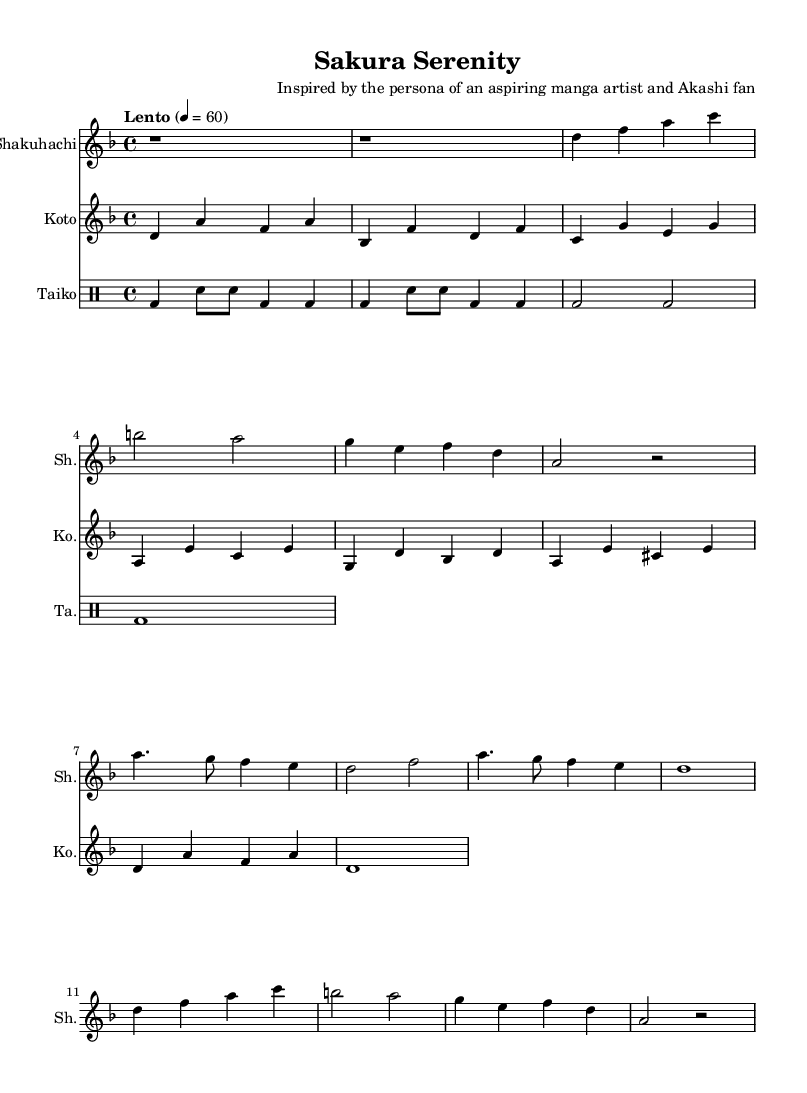What is the key signature of this music? The key signature is D minor, which has one flat (B♭) and indicates that the music is in a minor tonality.
Answer: D minor What is the time signature of this piece? The time signature indicates that there are four beats per measure, which is represented by 4/4. This means the music has a regular and even rhythm, typical in many forms of music, including traditional Japanese pieces.
Answer: 4/4 What is the tempo of this score? The tempo marking "Lento" indicates that the music should be played slowly. In this case, it is set at a metronome marking of 60 beats per minute, which is quite leisurely.
Answer: Lento, 60 What instruments are featured in this music? The music features three traditional Japanese instruments: Shakuhachi, Koto, and Taiko. Each instrument is represented by a separate staff, allowing for their distinct melodies or rhythms to be showcased.
Answer: Shakuhachi, Koto, Taiko What is the rhythmic pattern used by the Taiko? The Taiko part features a repeating pattern of bass drum (bd) and snare (sn) strokes, which creates a strong and driving rhythm, essential in traditional performance contexts. The pattern emphasizes the strong beats.
Answer: bd4 sn8 sn bd4 bd Which theme is repeated in the Shakuhachi part? Theme A from the Shakuhachi part is repeated, consisting of the notes d, f, a, c, b, a, g, e, f, and d. This repetition reinforces the theme's importance in the composition's structure.
Answer: Theme A 